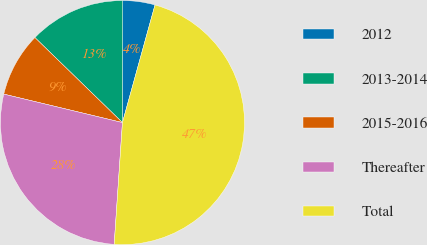Convert chart. <chart><loc_0><loc_0><loc_500><loc_500><pie_chart><fcel>2012<fcel>2013-2014<fcel>2015-2016<fcel>Thereafter<fcel>Total<nl><fcel>4.26%<fcel>12.77%<fcel>8.52%<fcel>27.67%<fcel>46.78%<nl></chart> 